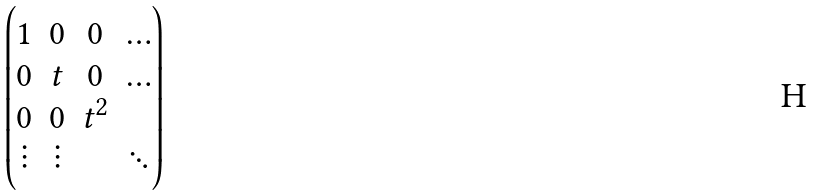Convert formula to latex. <formula><loc_0><loc_0><loc_500><loc_500>\begin{pmatrix} 1 & 0 & 0 & \hdots \\ 0 & t & 0 & \hdots \\ 0 & 0 & t ^ { 2 } & \\ \vdots & \vdots & & \ddots \end{pmatrix}</formula> 